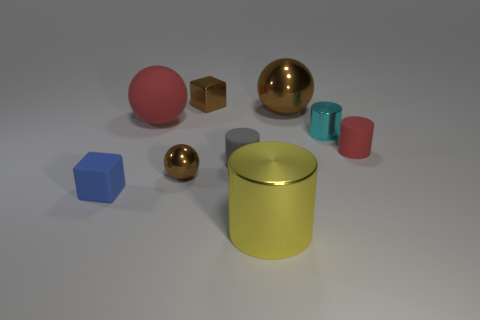Subtract all tiny cylinders. How many cylinders are left? 1 Subtract all cubes. How many objects are left? 7 Subtract 2 balls. How many balls are left? 1 Subtract all large metal blocks. Subtract all tiny blue matte objects. How many objects are left? 8 Add 1 tiny gray matte cylinders. How many tiny gray matte cylinders are left? 2 Add 1 cylinders. How many cylinders exist? 5 Subtract all yellow cylinders. How many cylinders are left? 3 Subtract 0 purple blocks. How many objects are left? 9 Subtract all blue spheres. Subtract all red blocks. How many spheres are left? 3 Subtract all brown cylinders. How many green blocks are left? 0 